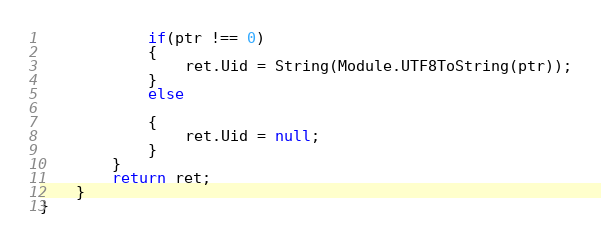Convert code to text. <code><loc_0><loc_0><loc_500><loc_500><_TypeScript_>			if(ptr !== 0)
			{
				ret.Uid = String(Module.UTF8ToString(ptr));
			}
			else
			
			{
				ret.Uid = null;
			}
		}
		return ret;
	}
}
</code> 